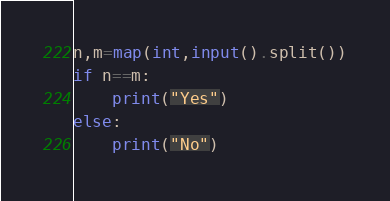Convert code to text. <code><loc_0><loc_0><loc_500><loc_500><_Python_>n,m=map(int,input().split())
if n==m:
    print("Yes")
else:
    print("No")
</code> 